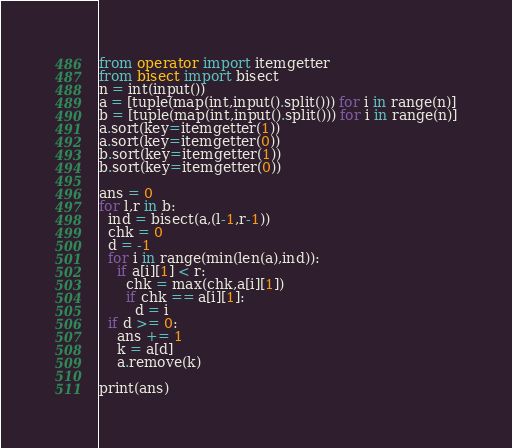<code> <loc_0><loc_0><loc_500><loc_500><_Python_>from operator import itemgetter
from bisect import bisect
n = int(input())
a = [tuple(map(int,input().split())) for i in range(n)]
b = [tuple(map(int,input().split())) for i in range(n)]
a.sort(key=itemgetter(1))
a.sort(key=itemgetter(0))
b.sort(key=itemgetter(1))
b.sort(key=itemgetter(0))

ans = 0
for l,r in b:
  ind = bisect(a,(l-1,r-1))
  chk = 0
  d = -1
  for i in range(min(len(a),ind)):
    if a[i][1] < r:
      chk = max(chk,a[i][1])
      if chk == a[i][1]:
        d = i
  if d >= 0:
    ans += 1
    k = a[d]
    a.remove(k)
    
print(ans)</code> 